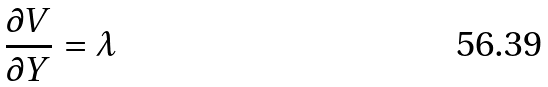<formula> <loc_0><loc_0><loc_500><loc_500>\frac { \partial V } { \partial Y } = \lambda</formula> 